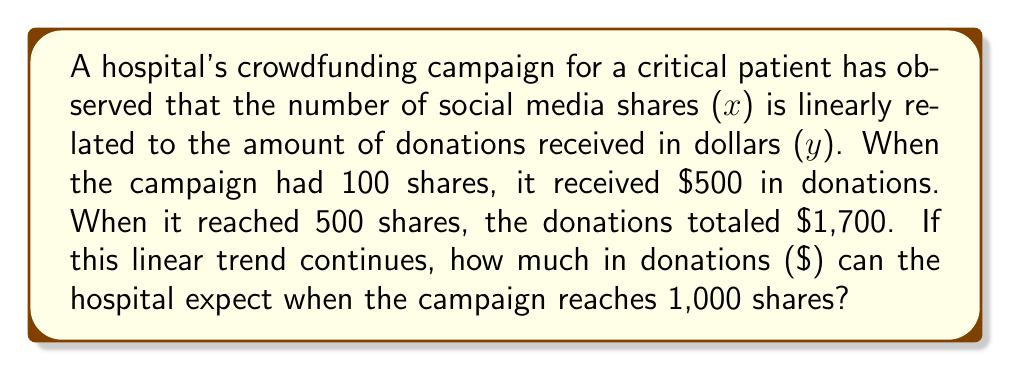Can you solve this math problem? Let's approach this step-by-step:

1) We're dealing with a linear relationship, so we can use the slope-intercept form of a line: $y = mx + b$

2) We need to find $m$ (slope) and $b$ (y-intercept) using the two given points:
   (100, 500) and (500, 1700)

3) Calculate the slope:
   $m = \frac{y_2 - y_1}{x_2 - x_1} = \frac{1700 - 500}{500 - 100} = \frac{1200}{400} = 3$

4) Now we can use either point to find $b$. Let's use (100, 500):
   $500 = 3(100) + b$
   $500 = 300 + b$
   $b = 200$

5) Our linear equation is: $y = 3x + 200$

6) To find the expected donations for 1,000 shares, substitute $x = 1000$:
   $y = 3(1000) + 200 = 3000 + 200 = 3200$

Therefore, if the linear trend continues, the hospital can expect $3,200 in donations when the campaign reaches 1,000 shares.
Answer: $3,200 